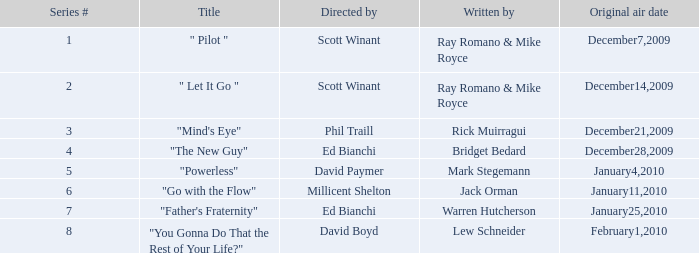What is the name of the episode penned by jack orman? "Go with the Flow". 